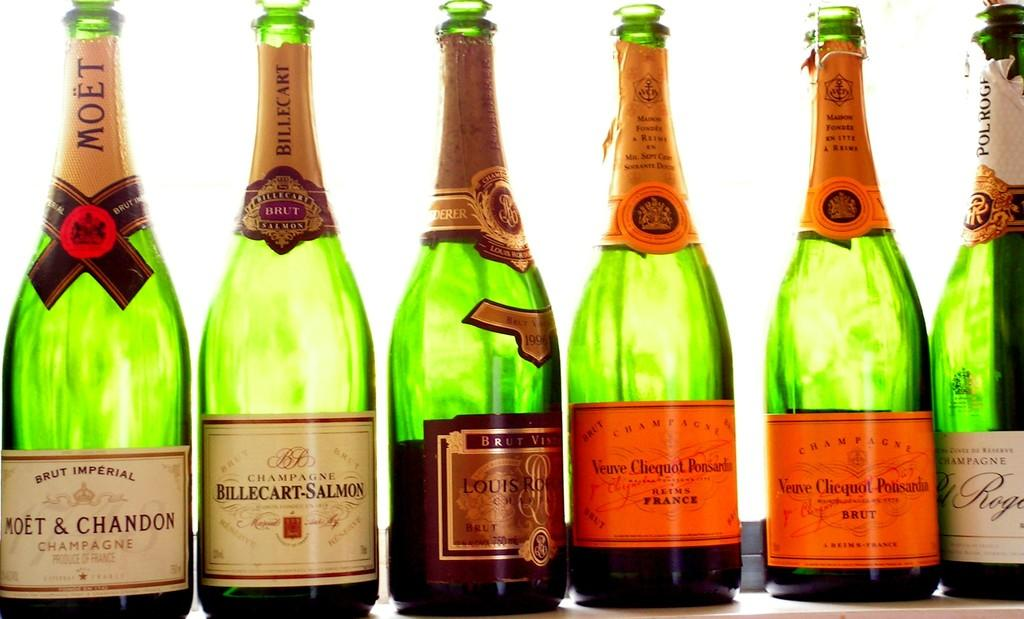<image>
Offer a succinct explanation of the picture presented. six bottles of champagne, one of which si moet and chandon 